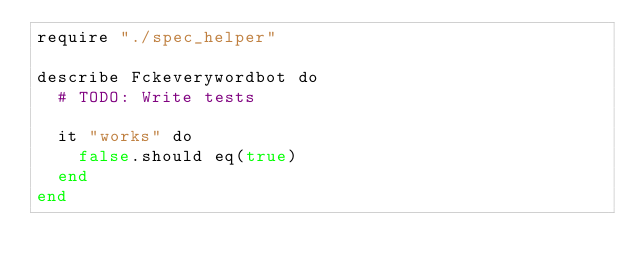Convert code to text. <code><loc_0><loc_0><loc_500><loc_500><_Crystal_>require "./spec_helper"

describe Fckeverywordbot do
  # TODO: Write tests

  it "works" do
    false.should eq(true)
  end
end
</code> 